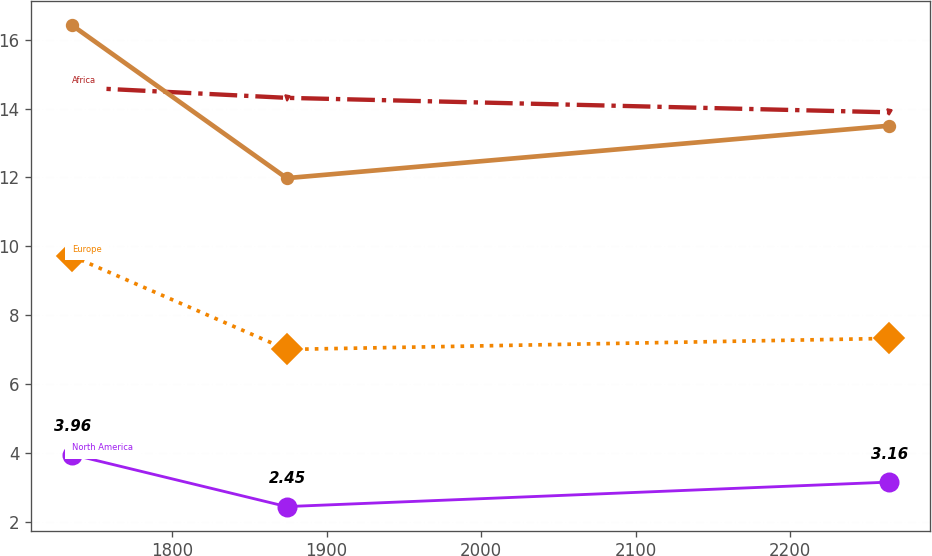Convert chart. <chart><loc_0><loc_0><loc_500><loc_500><line_chart><ecel><fcel>Africa<fcel>North America<fcel>Europe<fcel>Unnamed: 4<nl><fcel>1735.04<fcel>14.62<fcel>3.96<fcel>9.72<fcel>16.42<nl><fcel>1874.07<fcel>14.31<fcel>2.45<fcel>7.01<fcel>11.98<nl><fcel>2263.8<fcel>13.89<fcel>3.16<fcel>7.33<fcel>13.5<nl></chart> 